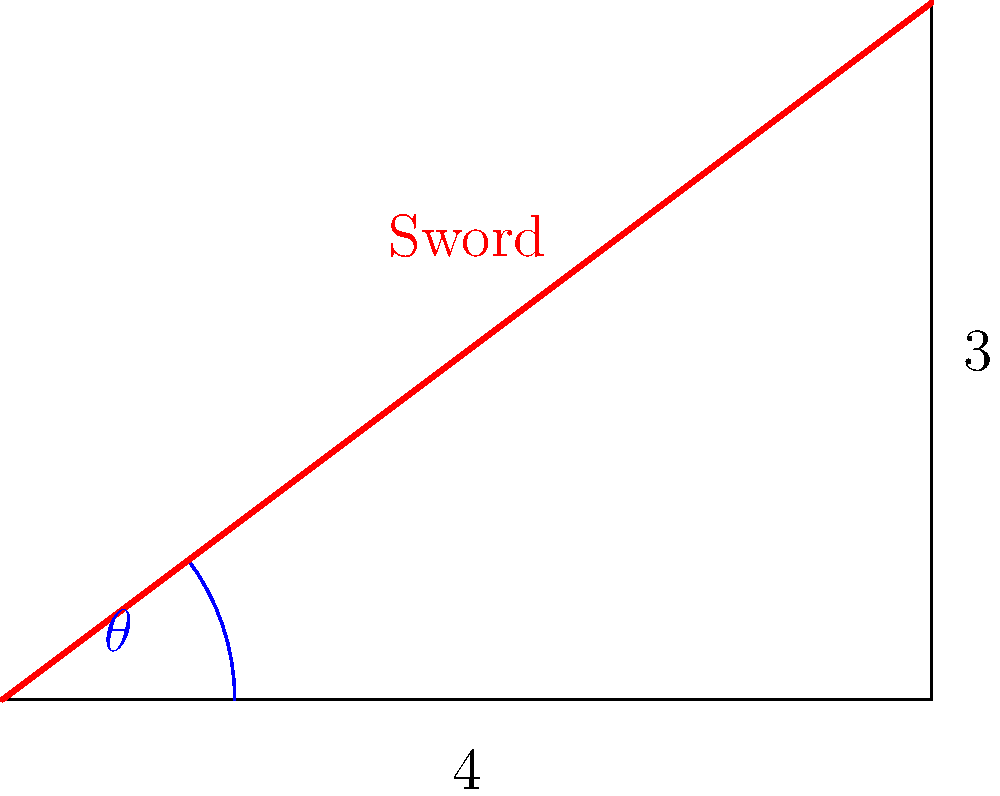In your latest hand-drawn illustration inspired by a classic video game character, you've depicted a warrior swinging a sword. The tip of the sword traces a right triangle during the swing. If the horizontal displacement of the sword tip is 4 units and the vertical displacement is 3 units, what is the angle $\theta$ (in degrees) of the sword's swing from its initial horizontal position? To solve this problem, we'll use the arctangent function, which is ideal for finding angles in right triangles when we know the opposite and adjacent sides. Here's the step-by-step solution:

1) In our right triangle, we have:
   - Opposite side (vertical displacement) = 3 units
   - Adjacent side (horizontal displacement) = 4 units

2) The tangent of an angle is defined as the ratio of the opposite side to the adjacent side:
   $\tan(\theta) = \frac{\text{opposite}}{\text{adjacent}} = \frac{3}{4}$

3) To find $\theta$, we need to use the inverse tangent (arctangent) function:
   $\theta = \arctan(\frac{3}{4})$

4) Using a calculator or computer, we can evaluate this:
   $\theta = \arctan(0.75) \approx 0.6435$ radians

5) The question asks for the angle in degrees, so we need to convert from radians to degrees:
   $\theta \text{ (in degrees)} = 0.6435 \times \frac{180°}{\pi} \approx 36.87°$

6) Rounding to two decimal places:
   $\theta \approx 36.87°$

This angle represents the sword's swing from its initial horizontal position in your illustration.
Answer: $36.87°$ 